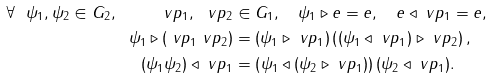<formula> <loc_0><loc_0><loc_500><loc_500>\forall \ \psi _ { 1 } , \psi _ { 2 } \in G _ { 2 } , \quad \ v p _ { 1 } , \ v p _ { 2 } & \in G _ { 1 } , \quad \psi _ { 1 } \triangleright e = e , \quad e \triangleleft \ v p _ { 1 } = e , \\ \psi _ { 1 } \triangleright ( \ v p _ { 1 } \ v p _ { 2 } ) & = ( \psi _ { 1 } \triangleright \ v p _ { 1 } ) \left ( ( \psi _ { 1 } \triangleleft \ v p _ { 1 } ) \triangleright \ v p _ { 2 } \right ) , \\ ( \psi _ { 1 } \psi _ { 2 } ) \triangleleft \ v p _ { 1 } & = \left ( \psi _ { 1 } \triangleleft ( \psi _ { 2 } \triangleright \ v p _ { 1 } ) \right ) ( \psi _ { 2 } \triangleleft \ v p _ { 1 } ) .</formula> 